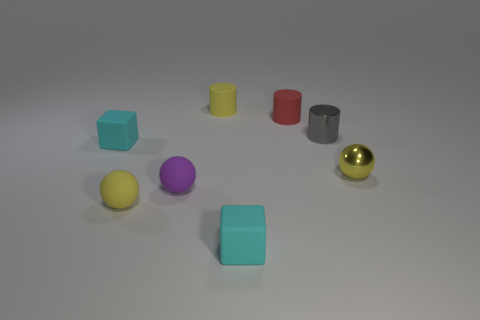Subtract all gray cubes. How many yellow balls are left? 2 Add 1 purple objects. How many objects exist? 9 Subtract all rubber spheres. How many spheres are left? 1 Subtract 1 cylinders. How many cylinders are left? 2 Subtract all cylinders. How many objects are left? 5 Subtract all cyan cylinders. Subtract all red cubes. How many cylinders are left? 3 Subtract all red balls. Subtract all small gray shiny cylinders. How many objects are left? 7 Add 6 gray metal cylinders. How many gray metal cylinders are left? 7 Add 3 red rubber cylinders. How many red rubber cylinders exist? 4 Subtract 0 cyan cylinders. How many objects are left? 8 